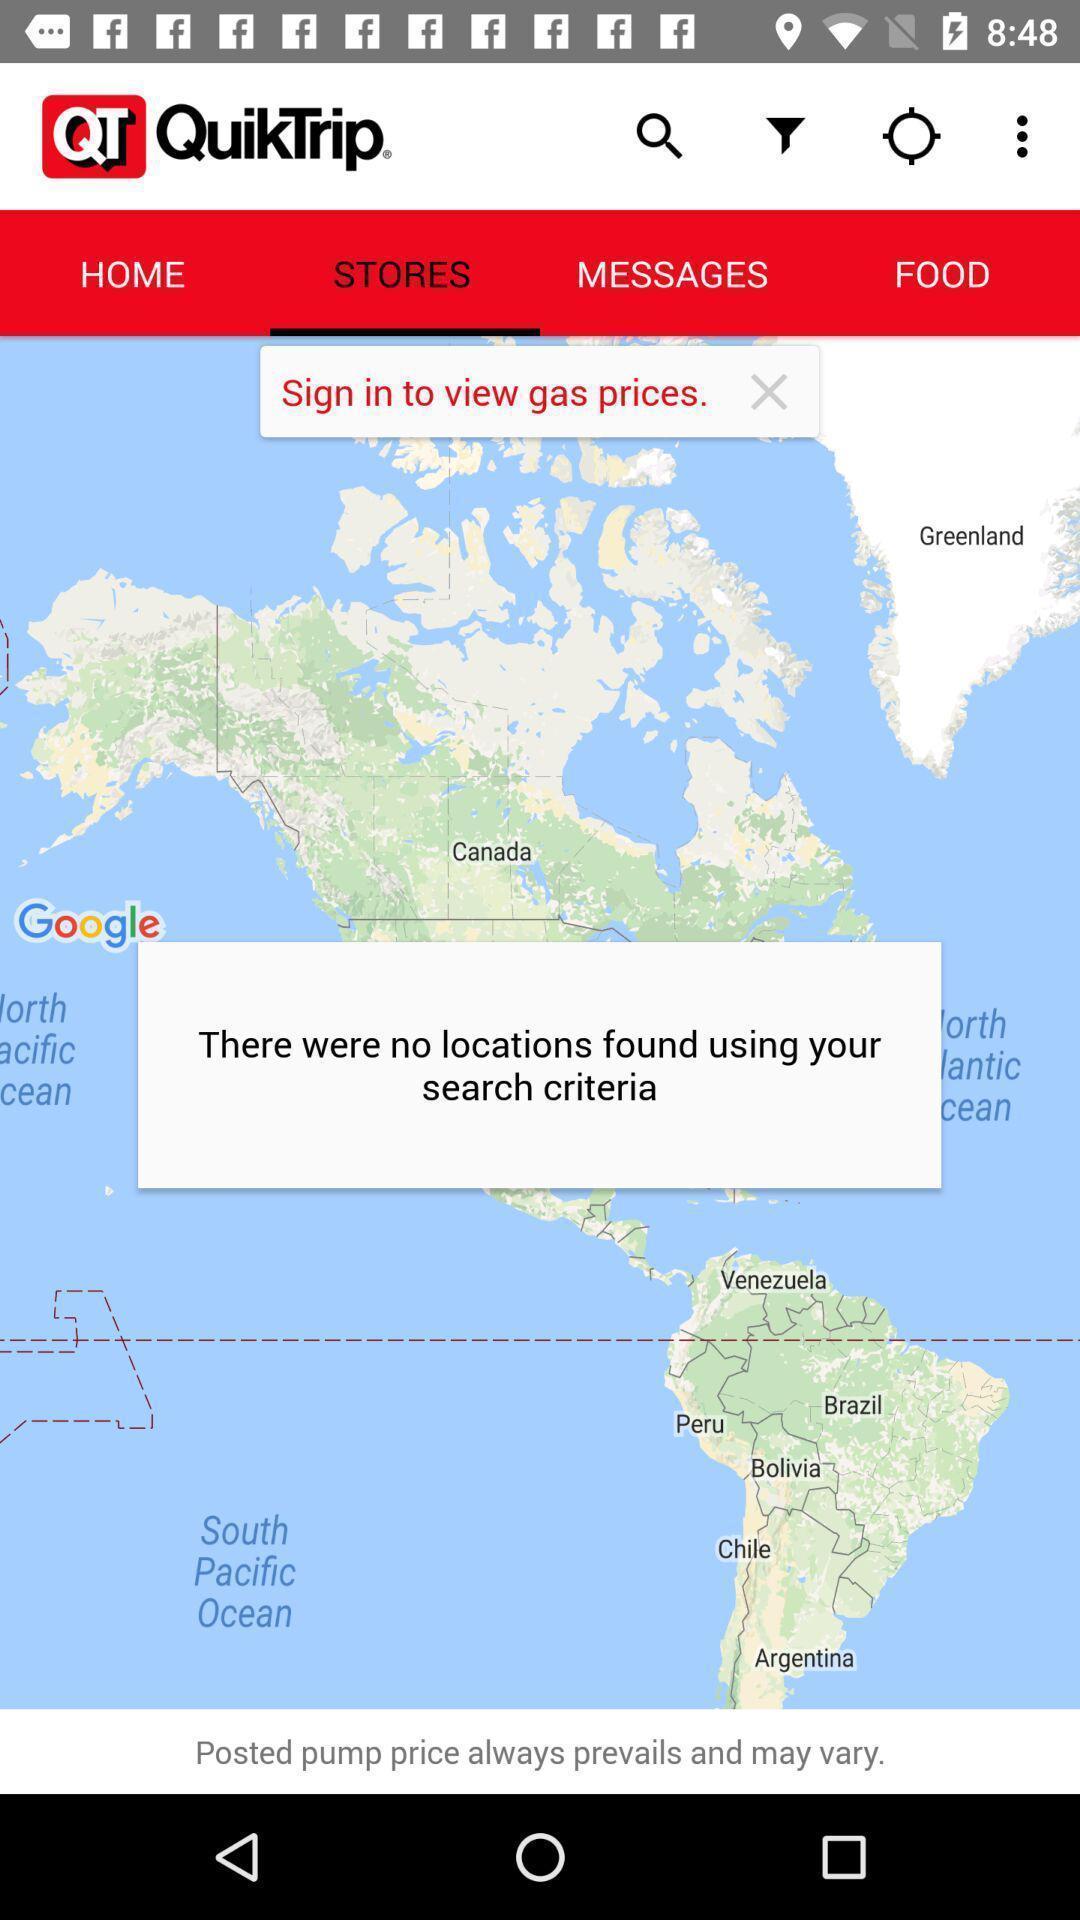Describe the visual elements of this screenshot. Pop-up displaying with no location results found for search. 